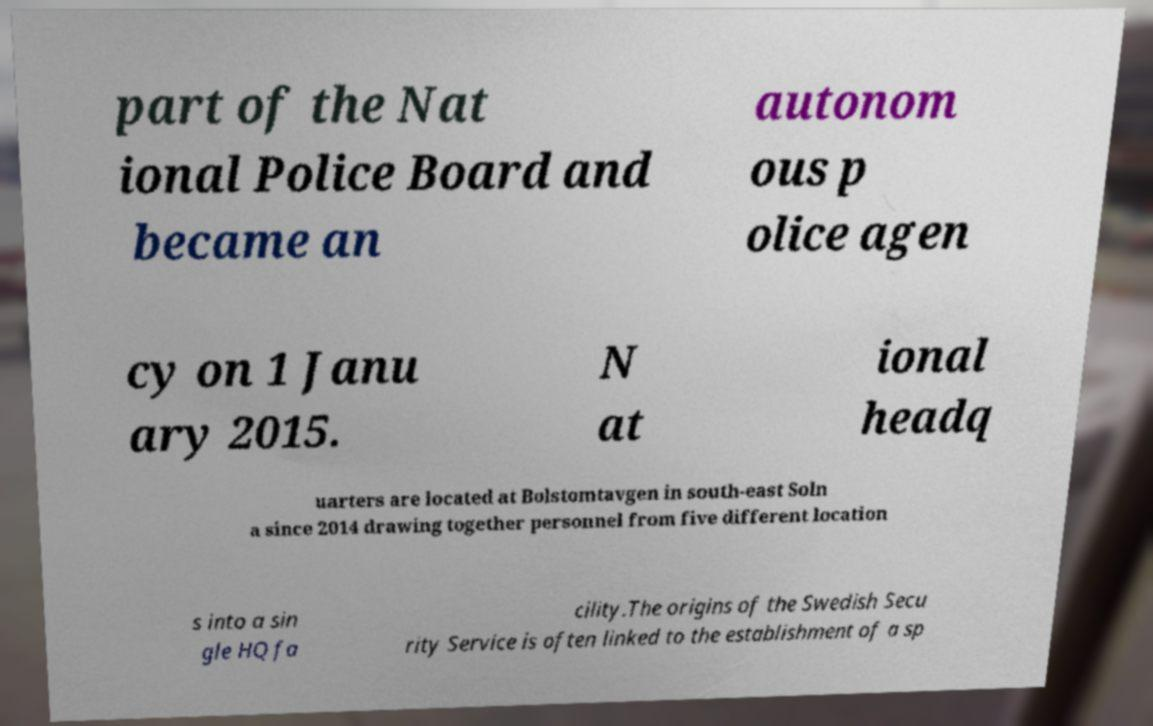There's text embedded in this image that I need extracted. Can you transcribe it verbatim? part of the Nat ional Police Board and became an autonom ous p olice agen cy on 1 Janu ary 2015. N at ional headq uarters are located at Bolstomtavgen in south-east Soln a since 2014 drawing together personnel from five different location s into a sin gle HQ fa cility.The origins of the Swedish Secu rity Service is often linked to the establishment of a sp 